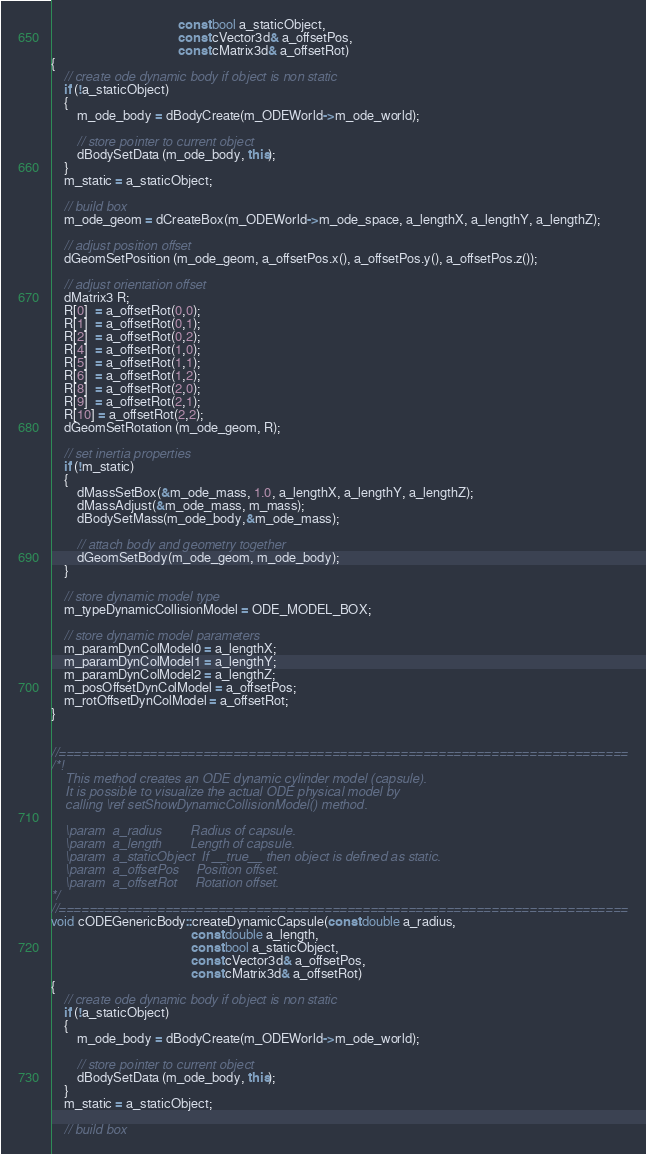Convert code to text. <code><loc_0><loc_0><loc_500><loc_500><_C++_>                                       const bool a_staticObject,
                                       const cVector3d& a_offsetPos,
                                       const cMatrix3d& a_offsetRot)
{
    // create ode dynamic body if object is non static
    if (!a_staticObject)
    {
        m_ode_body = dBodyCreate(m_ODEWorld->m_ode_world);

        // store pointer to current object
        dBodySetData (m_ode_body, this);
    }
    m_static = a_staticObject;

    // build box
    m_ode_geom = dCreateBox(m_ODEWorld->m_ode_space, a_lengthX, a_lengthY, a_lengthZ);

    // adjust position offset
    dGeomSetPosition (m_ode_geom, a_offsetPos.x(), a_offsetPos.y(), a_offsetPos.z());

    // adjust orientation offset
    dMatrix3 R;
    R[0]  = a_offsetRot(0,0);
    R[1]  = a_offsetRot(0,1);
    R[2]  = a_offsetRot(0,2);
    R[4]  = a_offsetRot(1,0);
    R[5]  = a_offsetRot(1,1);
    R[6]  = a_offsetRot(1,2);
    R[8]  = a_offsetRot(2,0);
    R[9]  = a_offsetRot(2,1);
    R[10] = a_offsetRot(2,2);
    dGeomSetRotation (m_ode_geom, R);

    // set inertia properties
    if (!m_static)
    {
        dMassSetBox(&m_ode_mass, 1.0, a_lengthX, a_lengthY, a_lengthZ);
        dMassAdjust(&m_ode_mass, m_mass);
        dBodySetMass(m_ode_body,&m_ode_mass);

        // attach body and geometry together
        dGeomSetBody(m_ode_geom, m_ode_body);
    }

    // store dynamic model type
    m_typeDynamicCollisionModel = ODE_MODEL_BOX;

    // store dynamic model parameters
    m_paramDynColModel0 = a_lengthX;
    m_paramDynColModel1 = a_lengthY;
    m_paramDynColModel2 = a_lengthZ;
    m_posOffsetDynColModel = a_offsetPos;
    m_rotOffsetDynColModel = a_offsetRot;
}


//===========================================================================
/*!
    This method creates an ODE dynamic cylinder model (capsule).
    It is possible to visualize the actual ODE physical model by
    calling \ref setShowDynamicCollisionModel() method.

    \param  a_radius        Radius of capsule.
    \param  a_length        Length of capsule.
    \param  a_staticObject  If __true__ then object is defined as static.
    \param  a_offsetPos     Position offset.
    \param  a_offsetRot     Rotation offset.
*/
//===========================================================================
void cODEGenericBody::createDynamicCapsule(const double a_radius,
                                           const double a_length,
                                           const bool a_staticObject,
                                           const cVector3d& a_offsetPos,
                                           const cMatrix3d& a_offsetRot)
{
    // create ode dynamic body if object is non static
    if (!a_staticObject)
    {
        m_ode_body = dBodyCreate(m_ODEWorld->m_ode_world);

        // store pointer to current object
        dBodySetData (m_ode_body, this);
    }
    m_static = a_staticObject;

    // build box</code> 